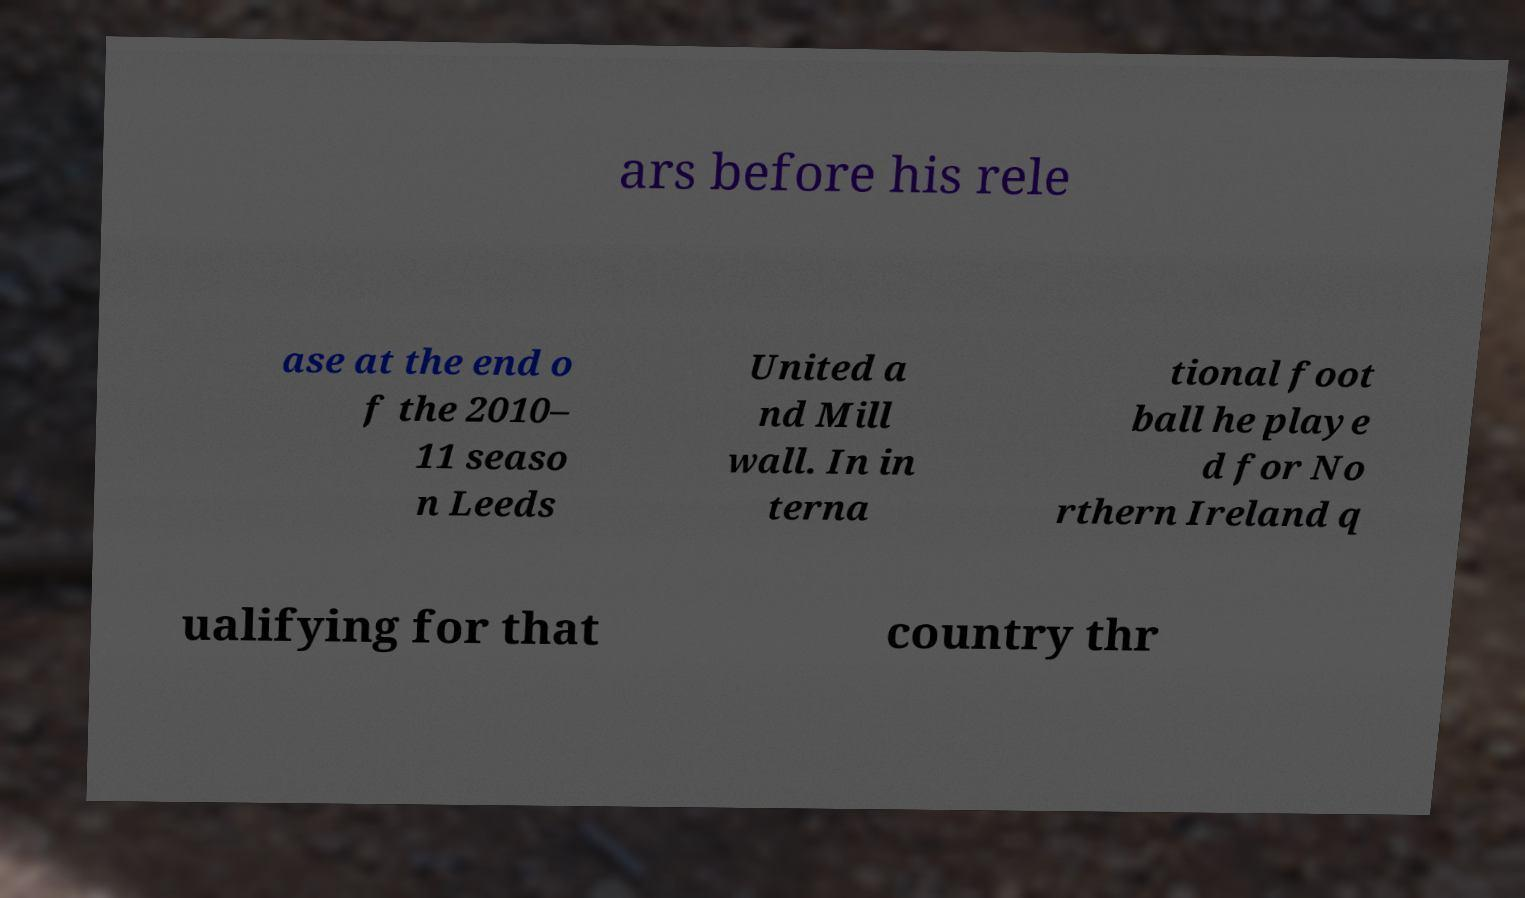I need the written content from this picture converted into text. Can you do that? ars before his rele ase at the end o f the 2010– 11 seaso n Leeds United a nd Mill wall. In in terna tional foot ball he playe d for No rthern Ireland q ualifying for that country thr 